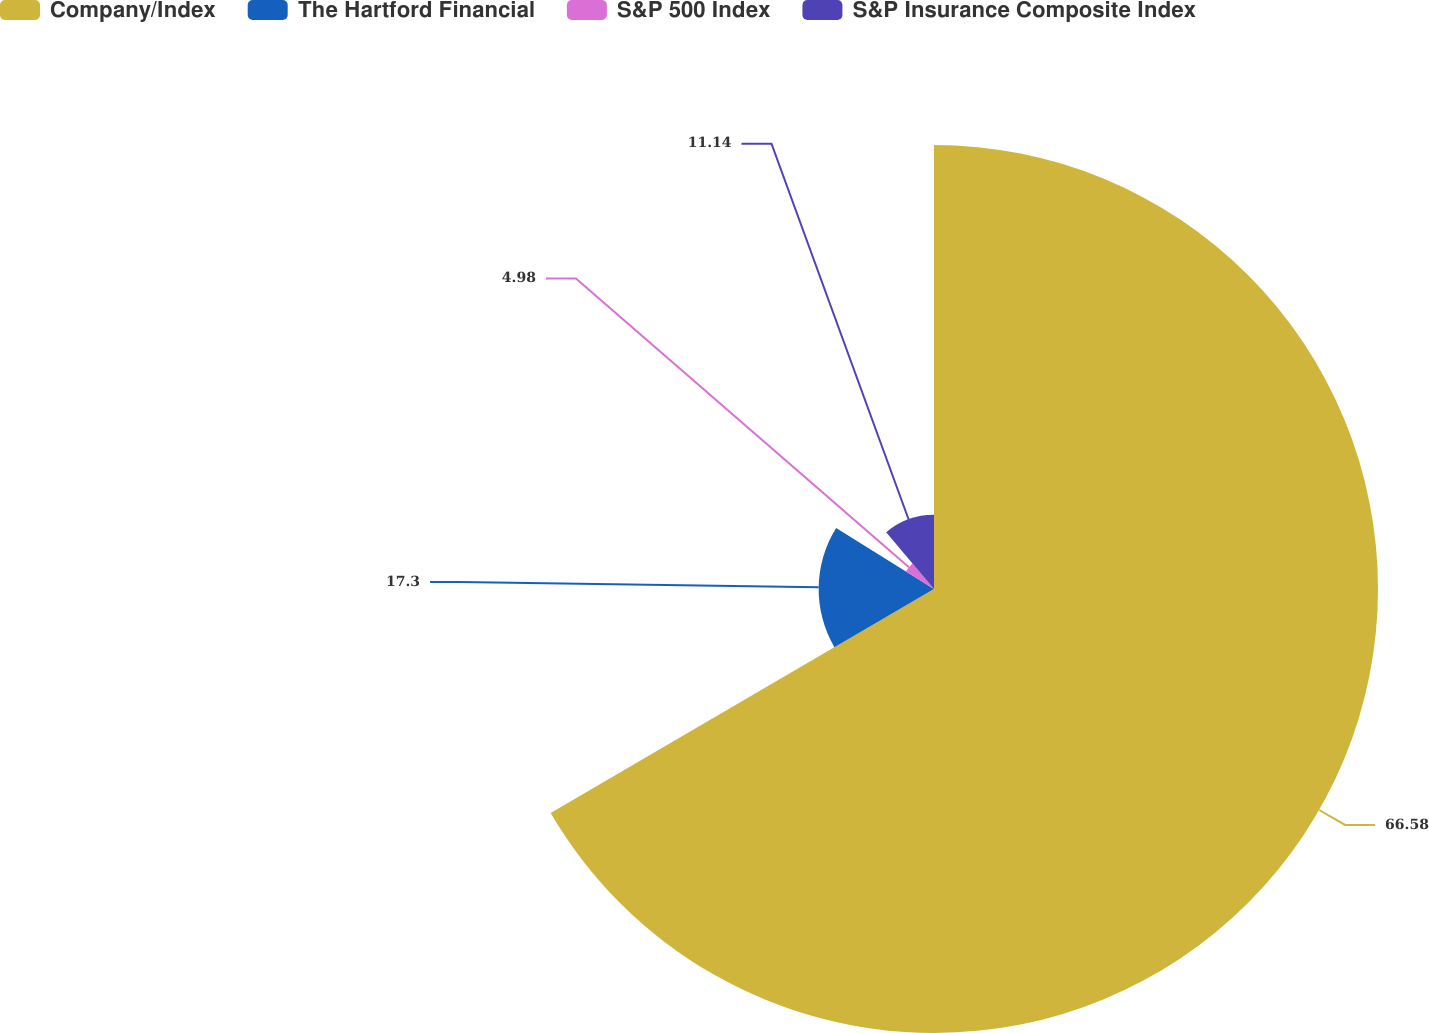Convert chart. <chart><loc_0><loc_0><loc_500><loc_500><pie_chart><fcel>Company/Index<fcel>The Hartford Financial<fcel>S&P 500 Index<fcel>S&P Insurance Composite Index<nl><fcel>66.59%<fcel>17.3%<fcel>4.98%<fcel>11.14%<nl></chart> 